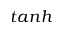<formula> <loc_0><loc_0><loc_500><loc_500>t a n h</formula> 